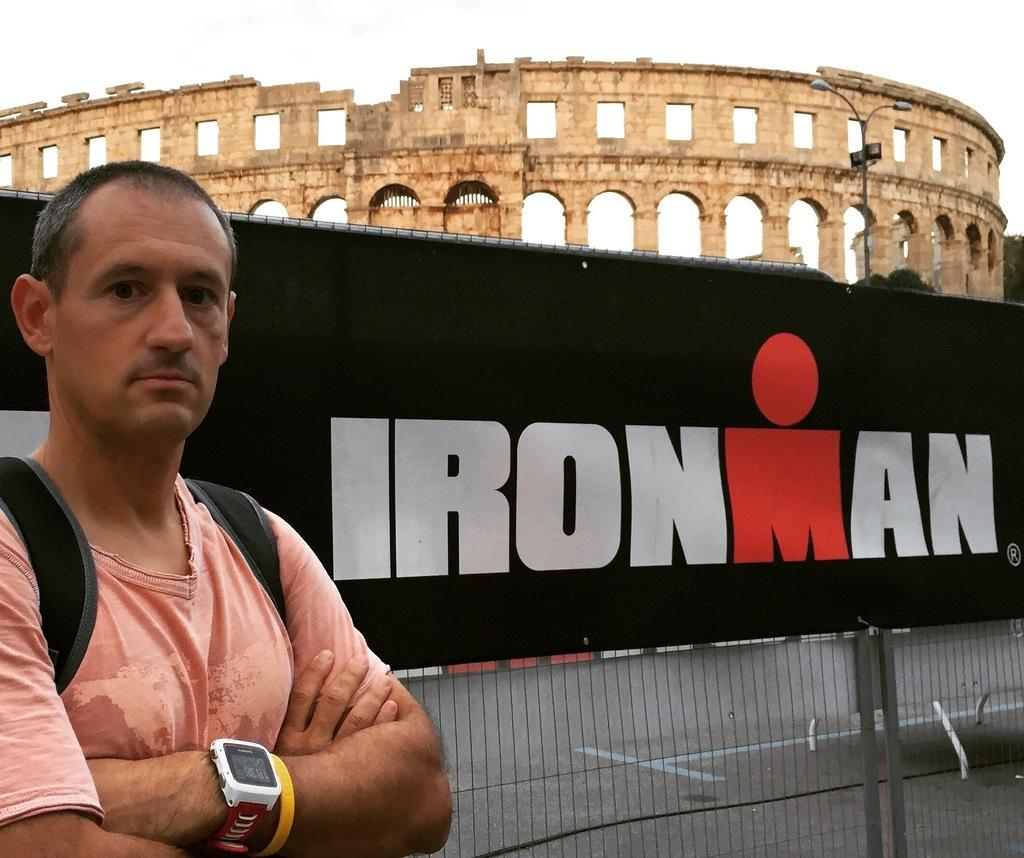Provide a one-sentence caption for the provided image. a person standing in front of the Roman Colosseum and Ironman sign. 